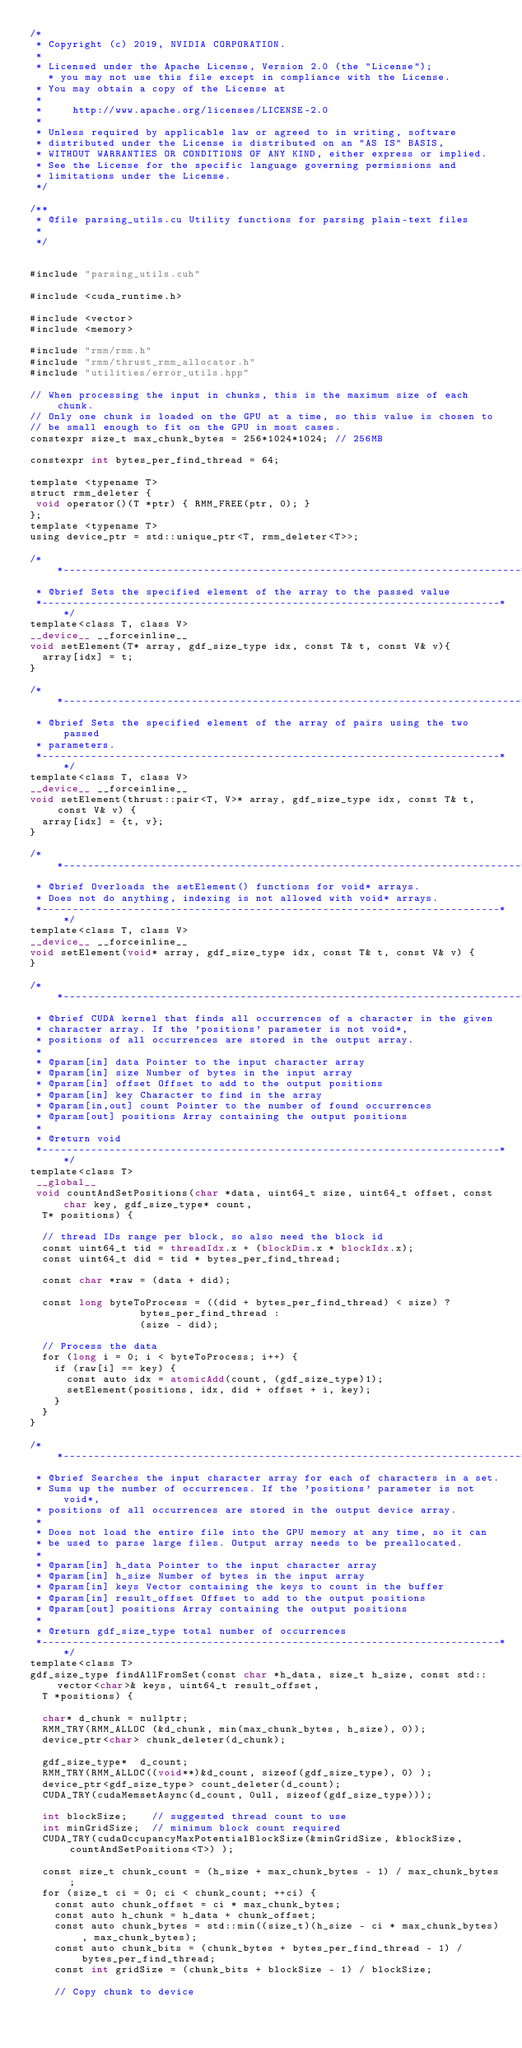<code> <loc_0><loc_0><loc_500><loc_500><_Cuda_>/*
 * Copyright (c) 2019, NVIDIA CORPORATION.
 *
 * Licensed under the Apache License, Version 2.0 (the "License");
	 * you may not use this file except in compliance with the License.
 * You may obtain a copy of the License at
 *
 *     http://www.apache.org/licenses/LICENSE-2.0
 *
 * Unless required by applicable law or agreed to in writing, software
 * distributed under the License is distributed on an "AS IS" BASIS,
 * WITHOUT WARRANTIES OR CONDITIONS OF ANY KIND, either express or implied.
 * See the License for the specific language governing permissions and
 * limitations under the License.
 */

/**
 * @file parsing_utils.cu Utility functions for parsing plain-text files
 *
 */


#include "parsing_utils.cuh"

#include <cuda_runtime.h>

#include <vector>
#include <memory>

#include "rmm/rmm.h"
#include "rmm/thrust_rmm_allocator.h"
#include "utilities/error_utils.hpp"

// When processing the input in chunks, this is the maximum size of each chunk.
// Only one chunk is loaded on the GPU at a time, so this value is chosen to
// be small enough to fit on the GPU in most cases.
constexpr size_t max_chunk_bytes = 256*1024*1024; // 256MB

constexpr int bytes_per_find_thread = 64;

template <typename T>
struct rmm_deleter {
 void operator()(T *ptr) { RMM_FREE(ptr, 0); }
};
template <typename T>
using device_ptr = std::unique_ptr<T, rmm_deleter<T>>;

/**---------------------------------------------------------------------------*
 * @brief Sets the specified element of the array to the passed value
 *---------------------------------------------------------------------------**/
template<class T, class V>
__device__ __forceinline__
void setElement(T* array, gdf_size_type idx, const T& t, const V& v){
	array[idx] = t;
}

/**---------------------------------------------------------------------------*
 * @brief Sets the specified element of the array of pairs using the two passed
 * parameters.
 *---------------------------------------------------------------------------**/
template<class T, class V>
__device__ __forceinline__
void setElement(thrust::pair<T, V>* array, gdf_size_type idx, const T& t, const V& v) {
	array[idx] = {t, v};
}

/**---------------------------------------------------------------------------*
 * @brief Overloads the setElement() functions for void* arrays.
 * Does not do anything, indexing is not allowed with void* arrays.
 *---------------------------------------------------------------------------**/
template<class T, class V>
__device__ __forceinline__
void setElement(void* array, gdf_size_type idx, const T& t, const V& v) {
}

/**---------------------------------------------------------------------------*
 * @brief CUDA kernel that finds all occurrences of a character in the given 
 * character array. If the 'positions' parameter is not void*,
 * positions of all occurrences are stored in the output array.
 * 
 * @param[in] data Pointer to the input character array
 * @param[in] size Number of bytes in the input array
 * @param[in] offset Offset to add to the output positions
 * @param[in] key Character to find in the array
 * @param[in,out] count Pointer to the number of found occurrences
 * @param[out] positions Array containing the output positions
 * 
 * @return void
 *---------------------------------------------------------------------------**/
template<class T>
 __global__ 
 void countAndSetPositions(char *data, uint64_t size, uint64_t offset, const char key, gdf_size_type* count,
	T* positions) {

	// thread IDs range per block, so also need the block id
	const uint64_t tid = threadIdx.x + (blockDim.x * blockIdx.x);
	const uint64_t did = tid * bytes_per_find_thread;
	
	const char *raw = (data + did);

	const long byteToProcess = ((did + bytes_per_find_thread) < size) ?
									bytes_per_find_thread :
									(size - did);

	// Process the data
	for (long i = 0; i < byteToProcess; i++) {
		if (raw[i] == key) {
			const auto idx = atomicAdd(count, (gdf_size_type)1);
			setElement(positions, idx, did + offset + i, key);
		}
	}
}

/**---------------------------------------------------------------------------*
 * @brief Searches the input character array for each of characters in a set.
 * Sums up the number of occurrences. If the 'positions' parameter is not void*,
 * positions of all occurrences are stored in the output device array.
 * 
 * Does not load the entire file into the GPU memory at any time, so it can 
 * be used to parse large files. Output array needs to be preallocated.
 * 
 * @param[in] h_data Pointer to the input character array
 * @param[in] h_size Number of bytes in the input array
 * @param[in] keys Vector containing the keys to count in the buffer
 * @param[in] result_offset Offset to add to the output positions
 * @param[out] positions Array containing the output positions
 * 
 * @return gdf_size_type total number of occurrences
 *---------------------------------------------------------------------------**/
template<class T>
gdf_size_type findAllFromSet(const char *h_data, size_t h_size, const std::vector<char>& keys, uint64_t result_offset,
	T *positions) {

	char* d_chunk = nullptr;
	RMM_TRY(RMM_ALLOC (&d_chunk, min(max_chunk_bytes, h_size), 0));
	device_ptr<char> chunk_deleter(d_chunk);

	gdf_size_type*	d_count;
	RMM_TRY(RMM_ALLOC((void**)&d_count, sizeof(gdf_size_type), 0) );
	device_ptr<gdf_size_type> count_deleter(d_count);
	CUDA_TRY(cudaMemsetAsync(d_count, 0ull, sizeof(gdf_size_type)));

	int blockSize;		// suggested thread count to use
	int minGridSize;	// minimum block count required
	CUDA_TRY(cudaOccupancyMaxPotentialBlockSize(&minGridSize, &blockSize, countAndSetPositions<T>) );

	const size_t chunk_count = (h_size + max_chunk_bytes - 1) / max_chunk_bytes;
	for (size_t ci = 0; ci < chunk_count; ++ci) {	
		const auto chunk_offset = ci * max_chunk_bytes;	
		const auto h_chunk = h_data + chunk_offset;
		const auto chunk_bytes = std::min((size_t)(h_size - ci * max_chunk_bytes), max_chunk_bytes);
		const auto chunk_bits = (chunk_bytes + bytes_per_find_thread - 1) / bytes_per_find_thread;
		const int gridSize = (chunk_bits + blockSize - 1) / blockSize;

		// Copy chunk to device</code> 